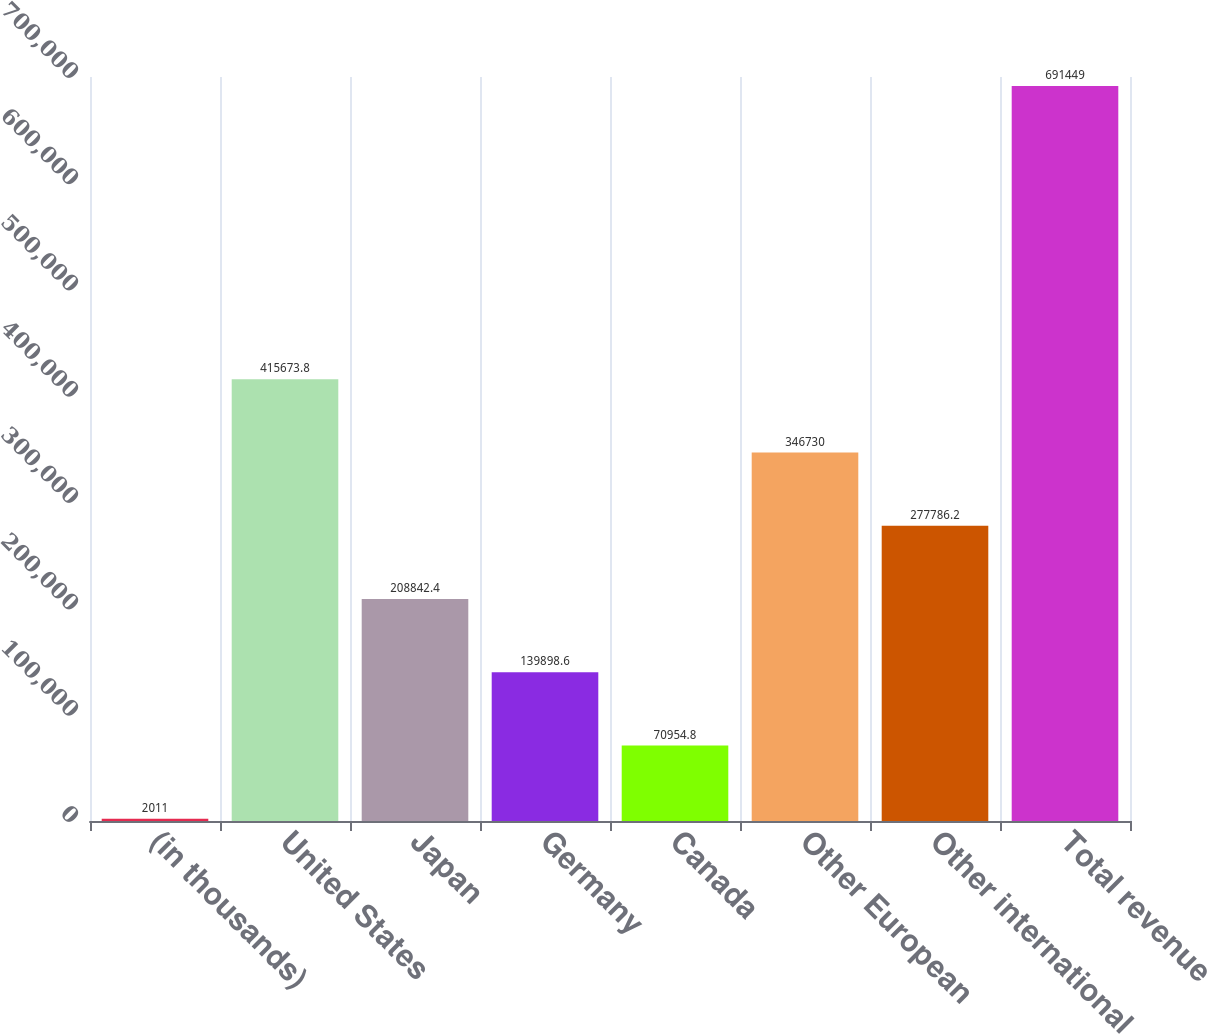Convert chart to OTSL. <chart><loc_0><loc_0><loc_500><loc_500><bar_chart><fcel>(in thousands)<fcel>United States<fcel>Japan<fcel>Germany<fcel>Canada<fcel>Other European<fcel>Other international<fcel>Total revenue<nl><fcel>2011<fcel>415674<fcel>208842<fcel>139899<fcel>70954.8<fcel>346730<fcel>277786<fcel>691449<nl></chart> 